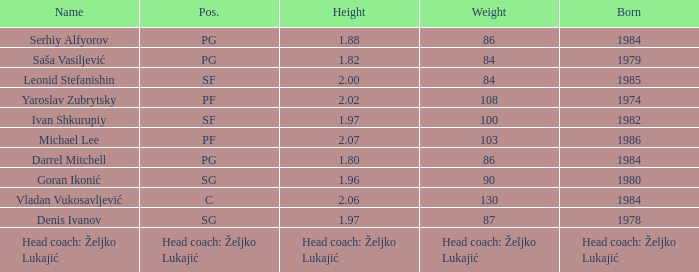Can you give me this table as a dict? {'header': ['Name', 'Pos.', 'Height', 'Weight', 'Born'], 'rows': [['Serhiy Alfyorov', 'PG', '1.88', '86', '1984'], ['Saša Vasiljević', 'PG', '1.82', '84', '1979'], ['Leonid Stefanishin', 'SF', '2.00', '84', '1985'], ['Yaroslav Zubrytsky', 'PF', '2.02', '108', '1974'], ['Ivan Shkurupiy', 'SF', '1.97', '100', '1982'], ['Michael Lee', 'PF', '2.07', '103', '1986'], ['Darrel Mitchell', 'PG', '1.80', '86', '1984'], ['Goran Ikonić', 'SG', '1.96', '90', '1980'], ['Vladan Vukosavljević', 'C', '2.06', '130', '1984'], ['Denis Ivanov', 'SG', '1.97', '87', '1978'], ['Head coach: Željko Lukajić', 'Head coach: Željko Lukajić', 'Head coach: Željko Lukajić', 'Head coach: Željko Lukajić', 'Head coach: Željko Lukajić']]} What is the position of the player born in 1984 with a height of 1.80m? PG. 